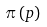Convert formula to latex. <formula><loc_0><loc_0><loc_500><loc_500>\pi \left ( p \right )</formula> 